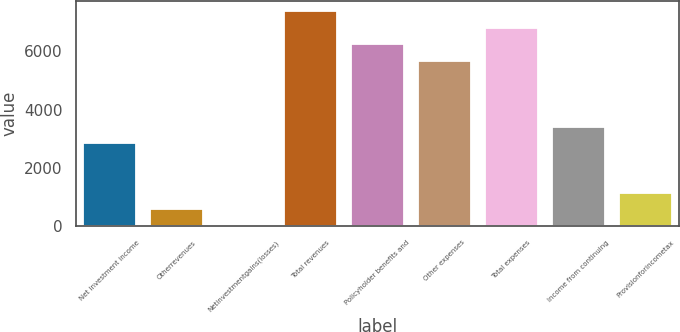Convert chart. <chart><loc_0><loc_0><loc_500><loc_500><bar_chart><fcel>Net investment income<fcel>Otherrevenues<fcel>Netinvestmentgains(losses)<fcel>Total revenues<fcel>Policyholder benefits and<fcel>Other expenses<fcel>Total expenses<fcel>Income from continuing<fcel>Provisionforincometax<nl><fcel>2843.5<fcel>580.7<fcel>15<fcel>7369.1<fcel>6237.7<fcel>5672<fcel>6803.4<fcel>3409.2<fcel>1146.4<nl></chart> 